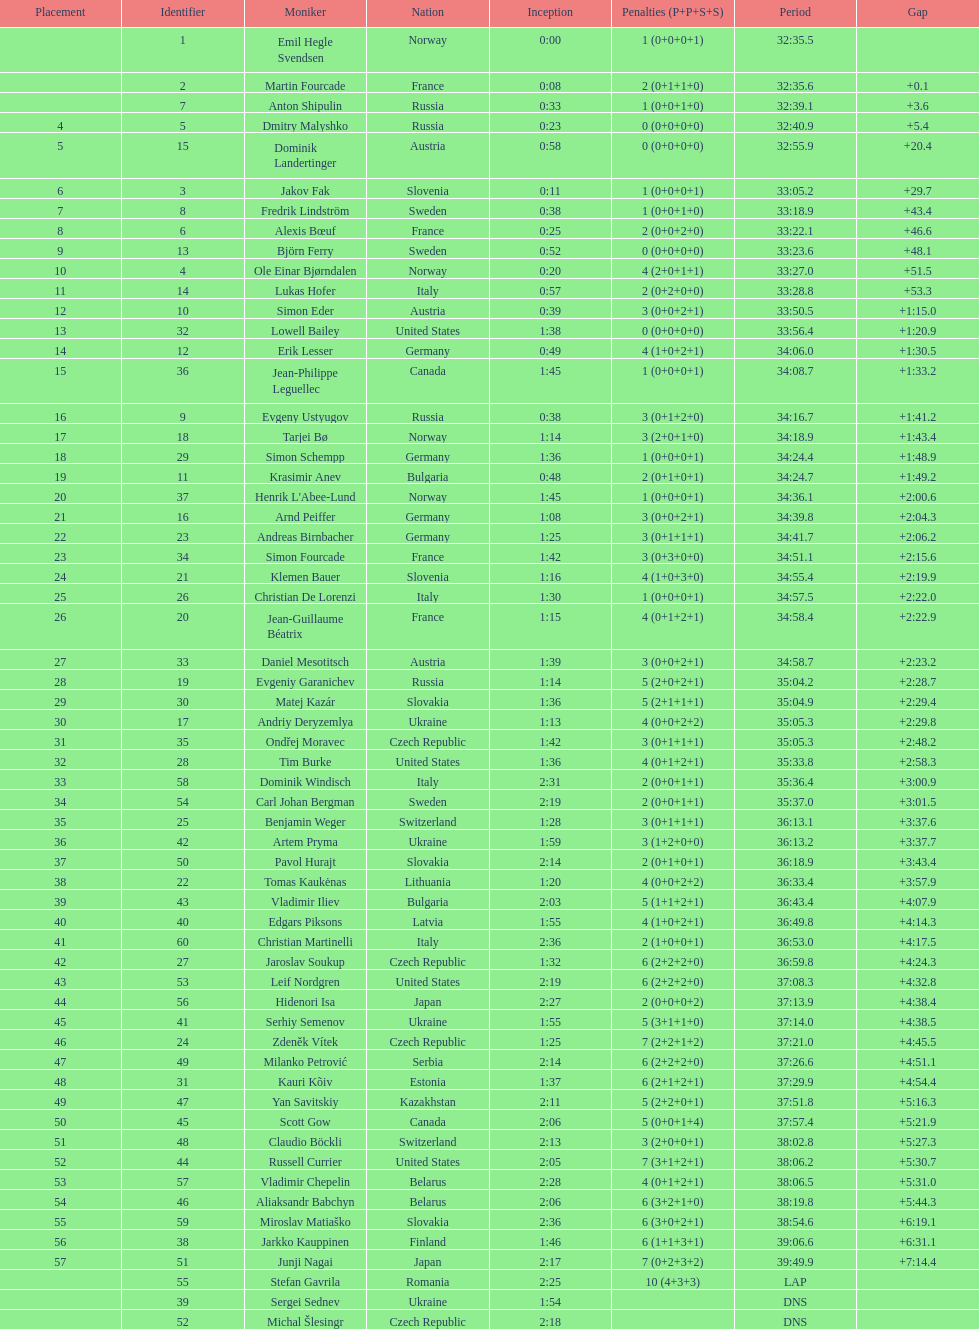Other than burke, name an athlete from the us. Leif Nordgren. 